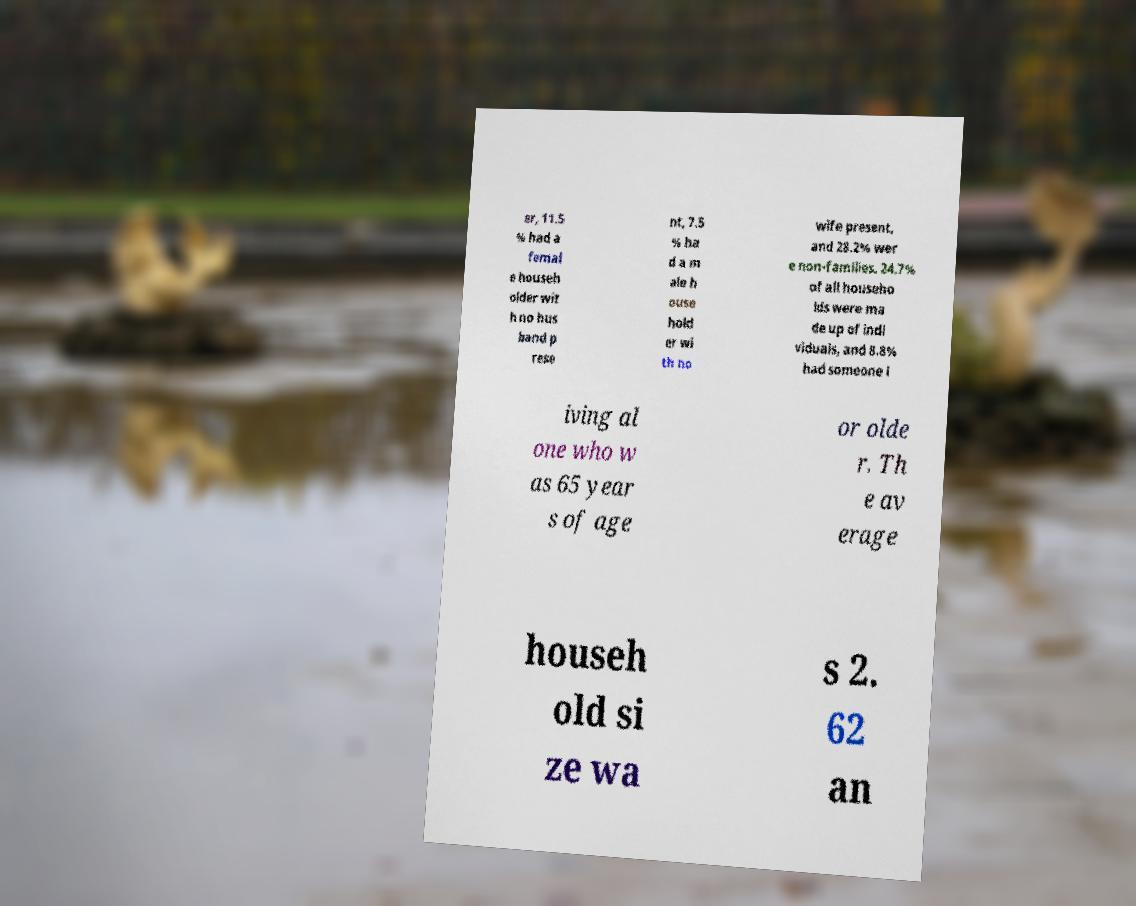What messages or text are displayed in this image? I need them in a readable, typed format. er, 11.5 % had a femal e househ older wit h no hus band p rese nt, 7.5 % ha d a m ale h ouse hold er wi th no wife present, and 28.2% wer e non-families. 24.7% of all househo lds were ma de up of indi viduals, and 8.8% had someone l iving al one who w as 65 year s of age or olde r. Th e av erage househ old si ze wa s 2. 62 an 